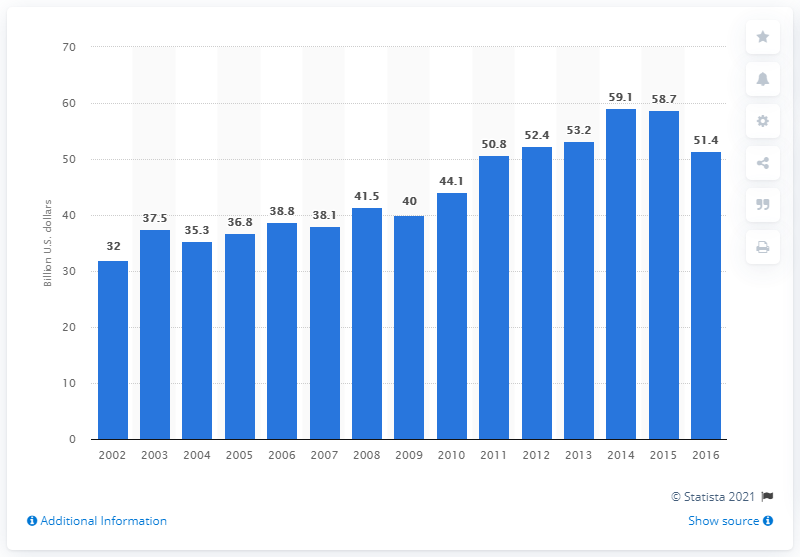Mention a couple of crucial points in this snapshot. In 2009, the value of U.S. product shipments of beef was approximately $40 million. 